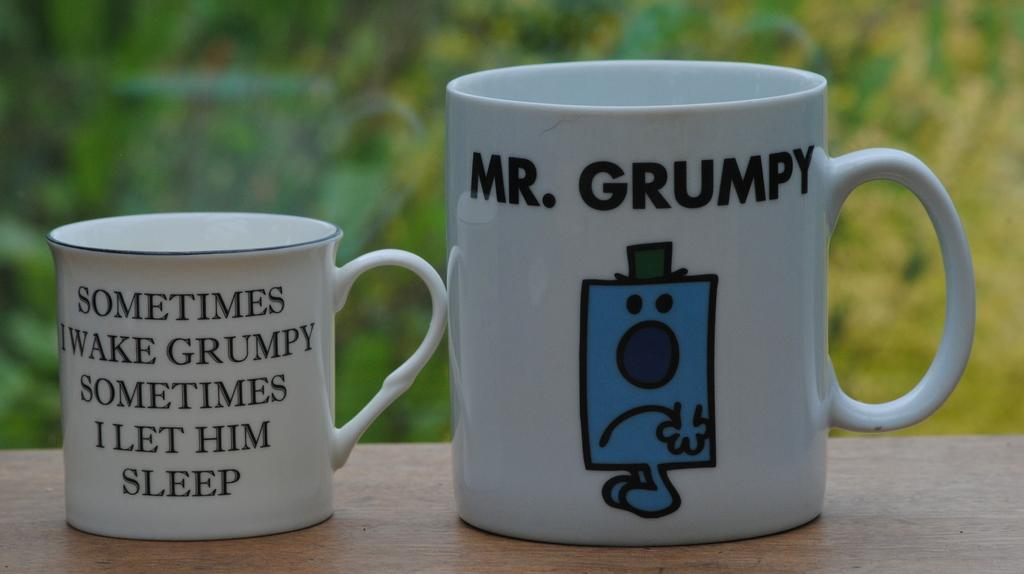<image>
Give a short and clear explanation of the subsequent image. Two coffee cups feature comical messages about a grumpy person. 